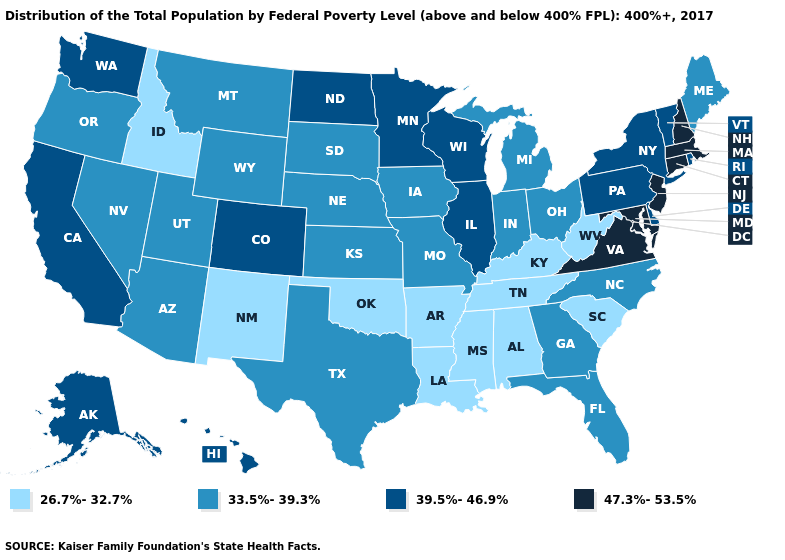Does the first symbol in the legend represent the smallest category?
Give a very brief answer. Yes. Name the states that have a value in the range 39.5%-46.9%?
Write a very short answer. Alaska, California, Colorado, Delaware, Hawaii, Illinois, Minnesota, New York, North Dakota, Pennsylvania, Rhode Island, Vermont, Washington, Wisconsin. Name the states that have a value in the range 33.5%-39.3%?
Answer briefly. Arizona, Florida, Georgia, Indiana, Iowa, Kansas, Maine, Michigan, Missouri, Montana, Nebraska, Nevada, North Carolina, Ohio, Oregon, South Dakota, Texas, Utah, Wyoming. Name the states that have a value in the range 39.5%-46.9%?
Keep it brief. Alaska, California, Colorado, Delaware, Hawaii, Illinois, Minnesota, New York, North Dakota, Pennsylvania, Rhode Island, Vermont, Washington, Wisconsin. Name the states that have a value in the range 47.3%-53.5%?
Answer briefly. Connecticut, Maryland, Massachusetts, New Hampshire, New Jersey, Virginia. What is the value of Indiana?
Short answer required. 33.5%-39.3%. What is the highest value in the South ?
Give a very brief answer. 47.3%-53.5%. Name the states that have a value in the range 26.7%-32.7%?
Write a very short answer. Alabama, Arkansas, Idaho, Kentucky, Louisiana, Mississippi, New Mexico, Oklahoma, South Carolina, Tennessee, West Virginia. Which states have the highest value in the USA?
Concise answer only. Connecticut, Maryland, Massachusetts, New Hampshire, New Jersey, Virginia. Name the states that have a value in the range 33.5%-39.3%?
Answer briefly. Arizona, Florida, Georgia, Indiana, Iowa, Kansas, Maine, Michigan, Missouri, Montana, Nebraska, Nevada, North Carolina, Ohio, Oregon, South Dakota, Texas, Utah, Wyoming. What is the value of Massachusetts?
Concise answer only. 47.3%-53.5%. Does Connecticut have the highest value in the USA?
Give a very brief answer. Yes. Does Missouri have a lower value than Colorado?
Write a very short answer. Yes. Does the first symbol in the legend represent the smallest category?
Be succinct. Yes. 